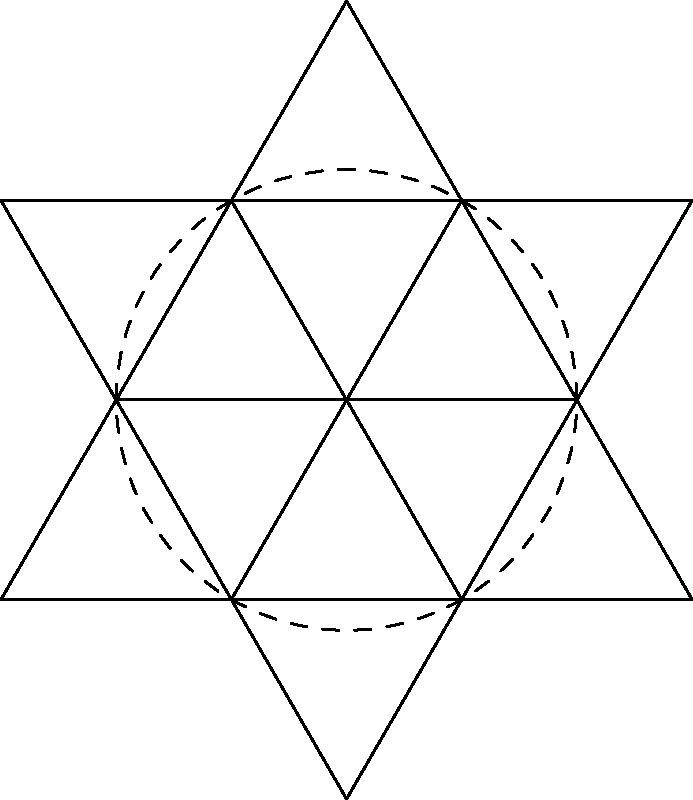Consider the geometric pattern found in the center of an ancient temple floor, as shown in the diagram. This pattern exhibits dihedral symmetry. If we denote the rotation symmetries as $r$ and the reflection symmetries as $s$, which of the following relations is true for the symmetry group of this pattern?

a) $r^6 = s^2 = e$, $srs = r^{-1}$
b) $r^6 = s^2 = e$, $srs = r$
c) $r^3 = s^2 = e$, $srs = r^{-1}$
d) $r^3 = s^2 = e$, $srs = r$ Let's analyze this step-by-step:

1) The pattern shows a hexagonal arrangement of equilateral triangles. This suggests it has 6-fold rotational symmetry.

2) There are also 6 lines of reflection symmetry (through the vertices and the midpoints of the sides of the hexagon).

3) These symmetries form the dihedral group $D_6$, which has order 12.

4) In the dihedral group $D_6$:
   - $r$ represents a rotation by 60°
   - $s$ represents a reflection

5) The relations for $D_6$ are:
   - $r^6 = e$ (six 60° rotations make a full 360°)
   - $s^2 = e$ (reflecting twice brings you back to the starting position)
   - $srs = r^{-1}$ (conjugation by reflection inverts rotation)

6) Examining the options:
   a) $r^6 = s^2 = e$, $srs = r^{-1}$ - This matches our analysis
   b) $r^6 = s^2 = e$, $srs = r$ - Incorrect conjugation relation
   c) $r^3 = s^2 = e$, $srs = r^{-1}$ - Incorrect order of rotation
   d) $r^3 = s^2 = e$, $srs = r$ - Incorrect order of rotation and conjugation relation

Therefore, option a) is correct.
Answer: a) $r^6 = s^2 = e$, $srs = r^{-1}$ 